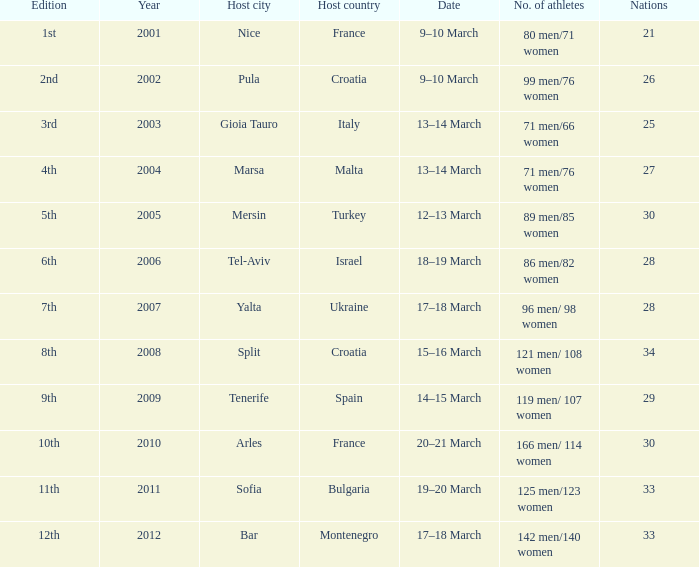What was the athlete count in nice, the host city? 80 men/71 women. 